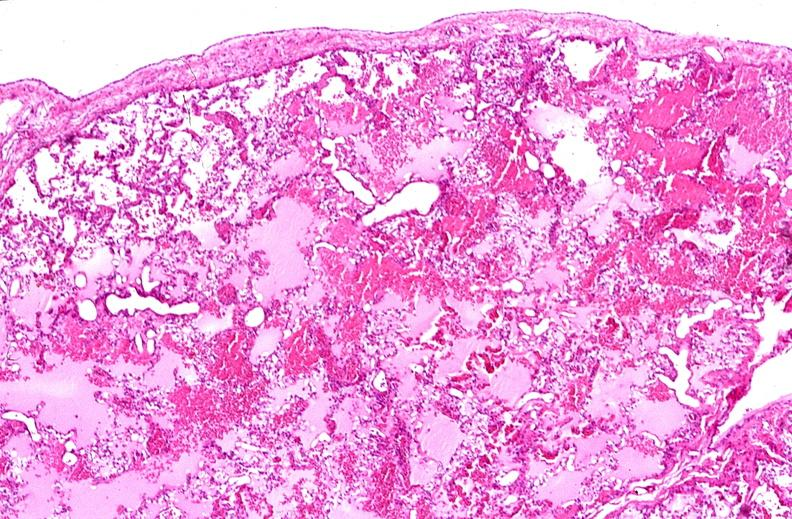s respiratory present?
Answer the question using a single word or phrase. Yes 